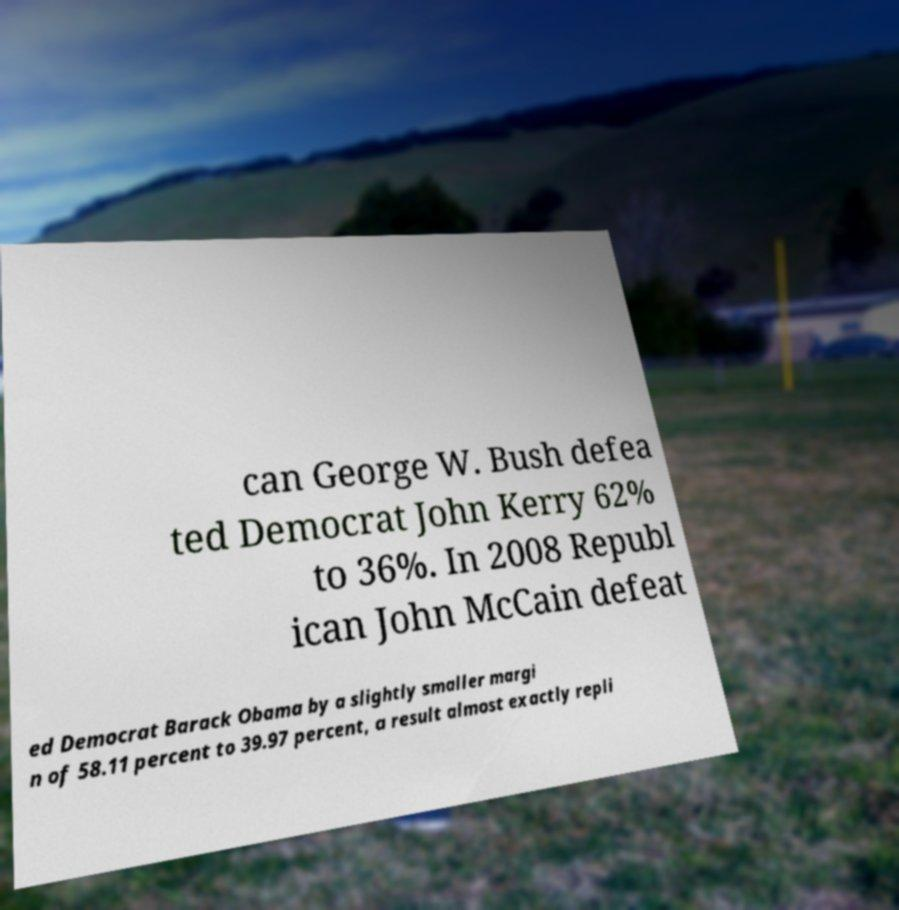Could you extract and type out the text from this image? can George W. Bush defea ted Democrat John Kerry 62% to 36%. In 2008 Republ ican John McCain defeat ed Democrat Barack Obama by a slightly smaller margi n of 58.11 percent to 39.97 percent, a result almost exactly repli 